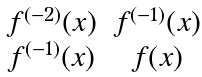Convert formula to latex. <formula><loc_0><loc_0><loc_500><loc_500>\begin{matrix} f ^ { ( - 2 ) } ( x ) & f ^ { ( - 1 ) } ( x ) \\ f ^ { ( - 1 ) } ( x ) & f ( x ) \end{matrix}</formula> 